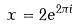<formula> <loc_0><loc_0><loc_500><loc_500>x = 2 e ^ { 2 \pi i }</formula> 